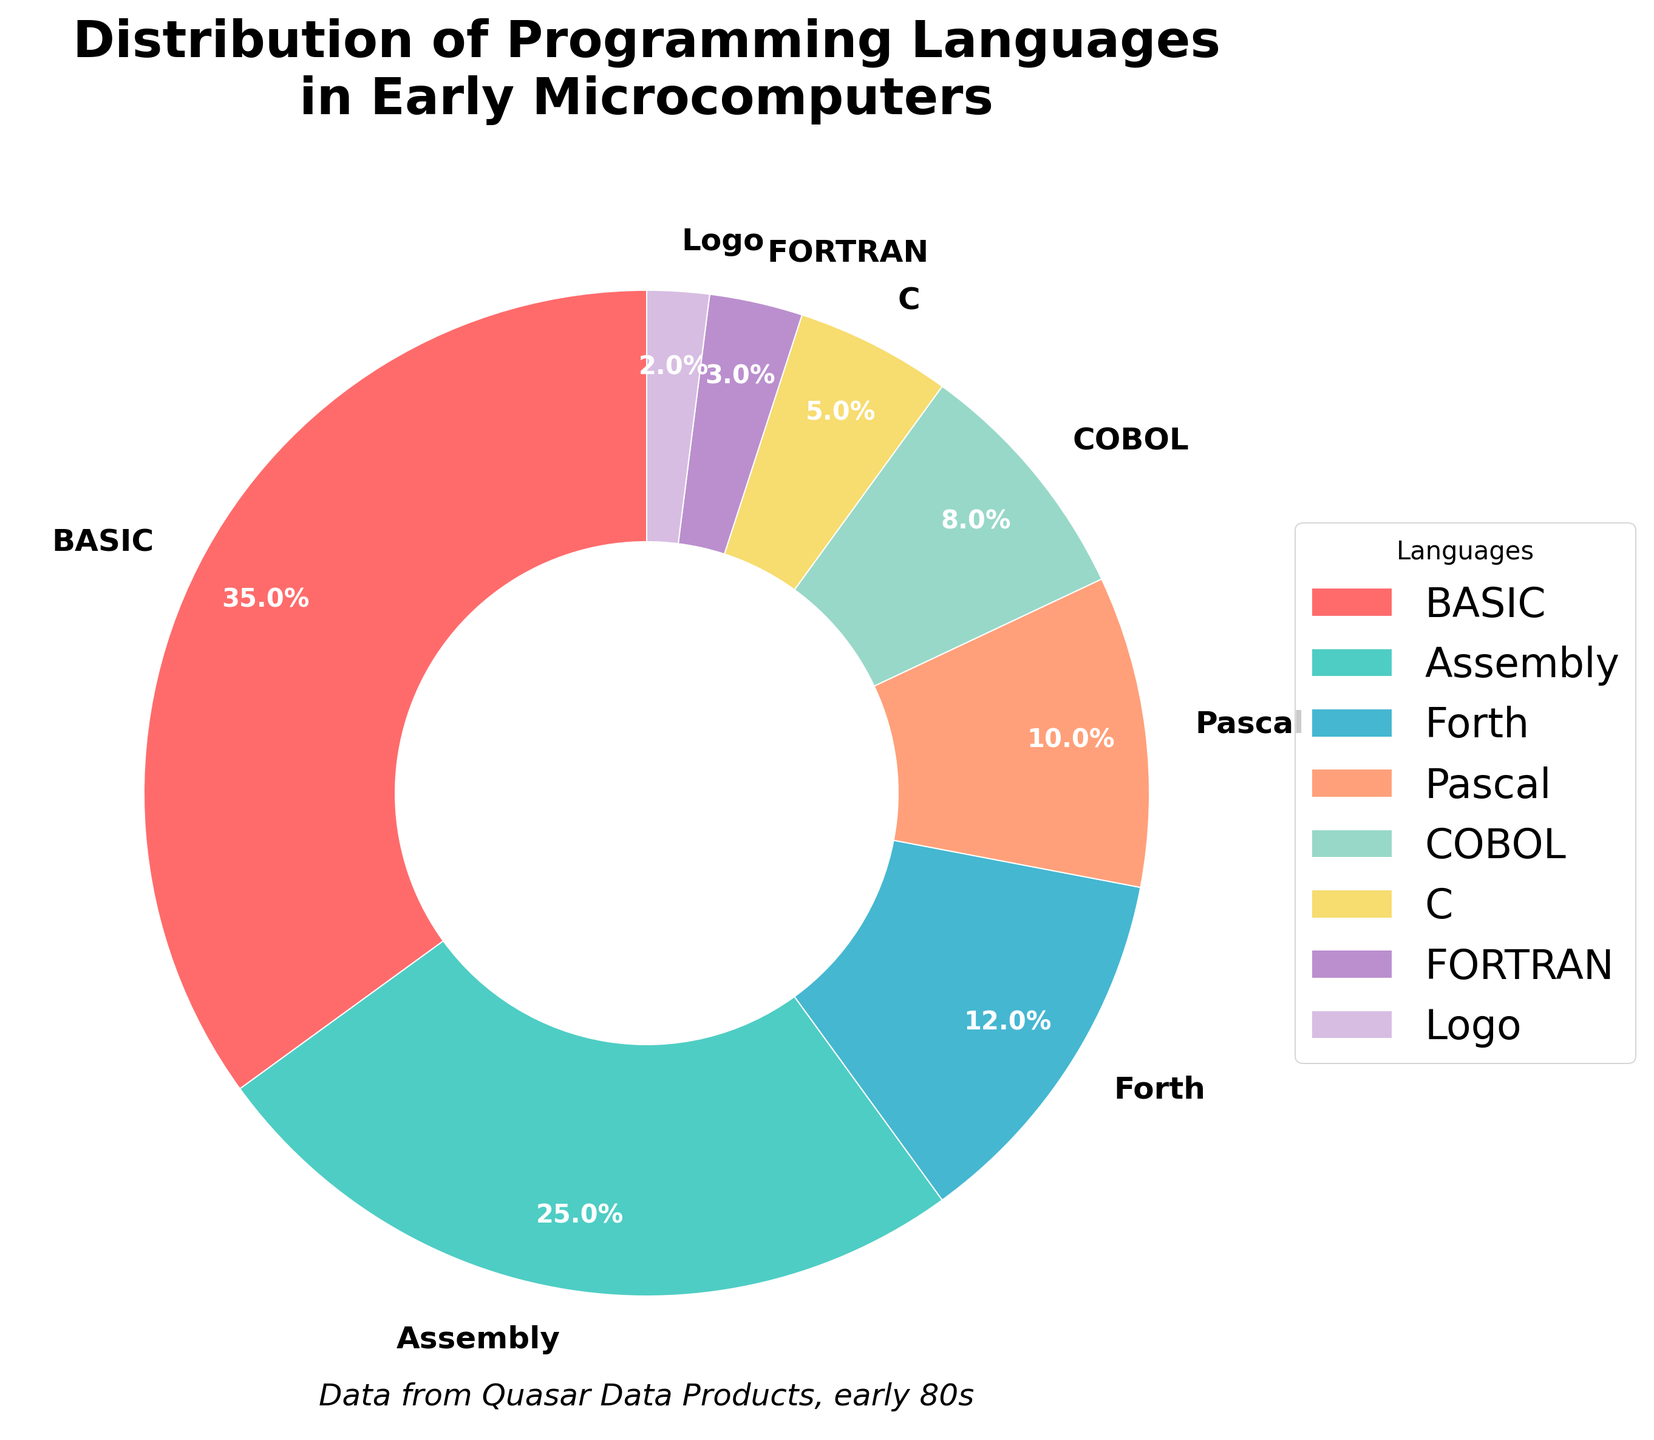Which programming language constitutes the largest proportion of usage in early microcomputers? By looking at the pie chart, the largest section represents the language with the highest percentage. The slice for BASIC occupies the largest area.
Answer: BASIC What is the combined percentage of Pascal and COBOL usage? The pie chart shows Pascal at 10% and COBOL at 8%. Adding these figures gives 10% + 8%.
Answer: 18% Which language has a higher usage percentage, Forth or Assembly? Comparing the slices for Forth (12%) and Assembly (25%) directly from the chart, clearly, Assembly has a higher percentage.
Answer: Assembly What is the difference in usage percentage between FORTRAN and Logo? FORTRAN has 3% usage, and Logo has 2% usage. The difference is calculated as 3% - 2%.
Answer: 1% Identify the language slice colored in deep pink and state its percentage. By inspecting the color representation, the deep pink slice corresponds to BASIC. The percentage for BASIC is 35%.
Answer: BASIC, 35% What is the visual relationship between the slice for C and the slice for Pascal? The slice for C (5%) is noticeably smaller than the slice for Pascal (10%), which is visually apparent.
Answer: Pascal's slice is larger What languages have a combined usage percentage less than that of BASIC? BASIC has 35%. Summing the languages with percentages less than 35% are Assembly (25%), Forth (12%), Pascal (10%), COBOL (8%), C (5%), FORTRAN (3%), and Logo (2%). Adding these percentages: 25% + 12% + 10% + 8% + 5% + 3% + 2% = 65%, so individually, all except BASIC are less than 35%.
Answer: Assembly, Forth, Pascal, COBOL, C, FORTRAN, Logo What is the average usage percentage of Assembly, Forth, and Pascal? The percentages for Assembly, Forth, and Pascal are 25%, 12%, and 10%, respectively. Summing these gives 25 + 12 + 10 = 47. Dividing by 3 languages gives 47/3.
Answer: 15.67 Which language group (Pascal, COBOL, or C) contributes less than 10% to the total distribution? Inspecting their respective percentages: Pascal (10%), COBOL (8%), C (5%). Both COBOL and C contribute less than 10%.
Answer: COBOL, C 